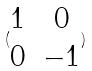<formula> <loc_0><loc_0><loc_500><loc_500>( \begin{matrix} 1 & 0 \\ 0 & - 1 \end{matrix} )</formula> 